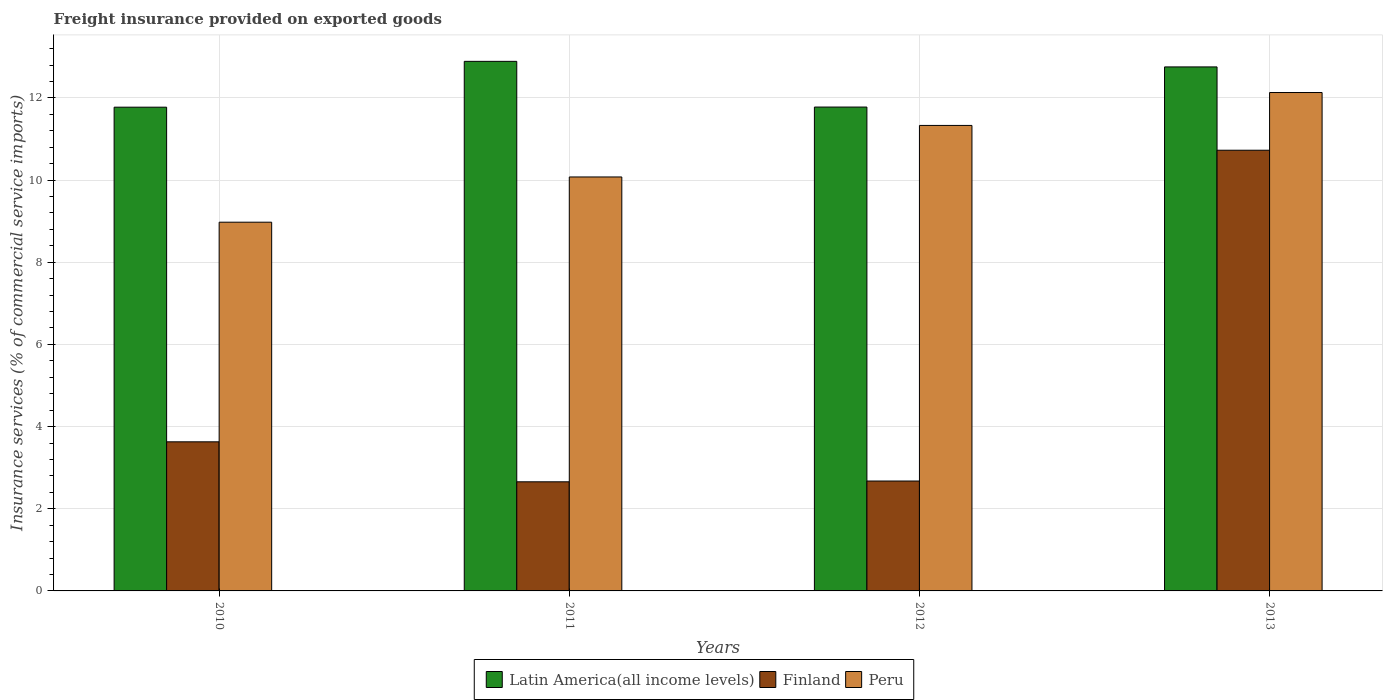How many different coloured bars are there?
Your answer should be very brief. 3. How many groups of bars are there?
Your answer should be compact. 4. Are the number of bars per tick equal to the number of legend labels?
Your response must be concise. Yes. What is the freight insurance provided on exported goods in Finland in 2012?
Your answer should be compact. 2.68. Across all years, what is the maximum freight insurance provided on exported goods in Finland?
Keep it short and to the point. 10.73. Across all years, what is the minimum freight insurance provided on exported goods in Latin America(all income levels)?
Provide a succinct answer. 11.77. In which year was the freight insurance provided on exported goods in Peru maximum?
Keep it short and to the point. 2013. What is the total freight insurance provided on exported goods in Finland in the graph?
Your response must be concise. 19.69. What is the difference between the freight insurance provided on exported goods in Finland in 2011 and that in 2012?
Your answer should be very brief. -0.02. What is the difference between the freight insurance provided on exported goods in Finland in 2010 and the freight insurance provided on exported goods in Latin America(all income levels) in 2013?
Your answer should be compact. -9.13. What is the average freight insurance provided on exported goods in Peru per year?
Your answer should be compact. 10.63. In the year 2011, what is the difference between the freight insurance provided on exported goods in Peru and freight insurance provided on exported goods in Finland?
Offer a terse response. 7.42. What is the ratio of the freight insurance provided on exported goods in Finland in 2011 to that in 2013?
Provide a short and direct response. 0.25. Is the difference between the freight insurance provided on exported goods in Peru in 2012 and 2013 greater than the difference between the freight insurance provided on exported goods in Finland in 2012 and 2013?
Offer a very short reply. Yes. What is the difference between the highest and the second highest freight insurance provided on exported goods in Peru?
Keep it short and to the point. 0.8. What is the difference between the highest and the lowest freight insurance provided on exported goods in Peru?
Keep it short and to the point. 3.16. In how many years, is the freight insurance provided on exported goods in Peru greater than the average freight insurance provided on exported goods in Peru taken over all years?
Give a very brief answer. 2. Is the sum of the freight insurance provided on exported goods in Latin America(all income levels) in 2010 and 2012 greater than the maximum freight insurance provided on exported goods in Peru across all years?
Your response must be concise. Yes. What does the 2nd bar from the left in 2010 represents?
Provide a succinct answer. Finland. What does the 1st bar from the right in 2012 represents?
Keep it short and to the point. Peru. How many bars are there?
Make the answer very short. 12. Are all the bars in the graph horizontal?
Your answer should be compact. No. What is the difference between two consecutive major ticks on the Y-axis?
Your answer should be compact. 2. Are the values on the major ticks of Y-axis written in scientific E-notation?
Make the answer very short. No. Does the graph contain any zero values?
Provide a succinct answer. No. Does the graph contain grids?
Keep it short and to the point. Yes. What is the title of the graph?
Ensure brevity in your answer.  Freight insurance provided on exported goods. Does "Uzbekistan" appear as one of the legend labels in the graph?
Your answer should be very brief. No. What is the label or title of the Y-axis?
Offer a very short reply. Insurance services (% of commercial service imports). What is the Insurance services (% of commercial service imports) of Latin America(all income levels) in 2010?
Your answer should be very brief. 11.77. What is the Insurance services (% of commercial service imports) of Finland in 2010?
Your answer should be very brief. 3.63. What is the Insurance services (% of commercial service imports) of Peru in 2010?
Provide a succinct answer. 8.98. What is the Insurance services (% of commercial service imports) of Latin America(all income levels) in 2011?
Offer a terse response. 12.89. What is the Insurance services (% of commercial service imports) in Finland in 2011?
Offer a terse response. 2.66. What is the Insurance services (% of commercial service imports) of Peru in 2011?
Your answer should be very brief. 10.08. What is the Insurance services (% of commercial service imports) in Latin America(all income levels) in 2012?
Your answer should be compact. 11.78. What is the Insurance services (% of commercial service imports) in Finland in 2012?
Your answer should be very brief. 2.68. What is the Insurance services (% of commercial service imports) in Peru in 2012?
Offer a terse response. 11.33. What is the Insurance services (% of commercial service imports) in Latin America(all income levels) in 2013?
Provide a succinct answer. 12.76. What is the Insurance services (% of commercial service imports) of Finland in 2013?
Offer a very short reply. 10.73. What is the Insurance services (% of commercial service imports) of Peru in 2013?
Offer a very short reply. 12.13. Across all years, what is the maximum Insurance services (% of commercial service imports) of Latin America(all income levels)?
Provide a short and direct response. 12.89. Across all years, what is the maximum Insurance services (% of commercial service imports) in Finland?
Offer a terse response. 10.73. Across all years, what is the maximum Insurance services (% of commercial service imports) of Peru?
Offer a terse response. 12.13. Across all years, what is the minimum Insurance services (% of commercial service imports) of Latin America(all income levels)?
Ensure brevity in your answer.  11.77. Across all years, what is the minimum Insurance services (% of commercial service imports) in Finland?
Keep it short and to the point. 2.66. Across all years, what is the minimum Insurance services (% of commercial service imports) in Peru?
Your answer should be compact. 8.98. What is the total Insurance services (% of commercial service imports) of Latin America(all income levels) in the graph?
Your answer should be very brief. 49.2. What is the total Insurance services (% of commercial service imports) in Finland in the graph?
Your response must be concise. 19.69. What is the total Insurance services (% of commercial service imports) of Peru in the graph?
Keep it short and to the point. 42.51. What is the difference between the Insurance services (% of commercial service imports) of Latin America(all income levels) in 2010 and that in 2011?
Your answer should be very brief. -1.12. What is the difference between the Insurance services (% of commercial service imports) of Finland in 2010 and that in 2011?
Offer a terse response. 0.97. What is the difference between the Insurance services (% of commercial service imports) of Peru in 2010 and that in 2011?
Offer a terse response. -1.1. What is the difference between the Insurance services (% of commercial service imports) in Latin America(all income levels) in 2010 and that in 2012?
Offer a very short reply. -0. What is the difference between the Insurance services (% of commercial service imports) of Finland in 2010 and that in 2012?
Offer a very short reply. 0.95. What is the difference between the Insurance services (% of commercial service imports) in Peru in 2010 and that in 2012?
Make the answer very short. -2.36. What is the difference between the Insurance services (% of commercial service imports) in Latin America(all income levels) in 2010 and that in 2013?
Give a very brief answer. -0.98. What is the difference between the Insurance services (% of commercial service imports) in Finland in 2010 and that in 2013?
Your answer should be very brief. -7.1. What is the difference between the Insurance services (% of commercial service imports) of Peru in 2010 and that in 2013?
Your response must be concise. -3.16. What is the difference between the Insurance services (% of commercial service imports) of Latin America(all income levels) in 2011 and that in 2012?
Ensure brevity in your answer.  1.11. What is the difference between the Insurance services (% of commercial service imports) of Finland in 2011 and that in 2012?
Your response must be concise. -0.02. What is the difference between the Insurance services (% of commercial service imports) of Peru in 2011 and that in 2012?
Keep it short and to the point. -1.25. What is the difference between the Insurance services (% of commercial service imports) of Latin America(all income levels) in 2011 and that in 2013?
Make the answer very short. 0.14. What is the difference between the Insurance services (% of commercial service imports) of Finland in 2011 and that in 2013?
Provide a succinct answer. -8.07. What is the difference between the Insurance services (% of commercial service imports) of Peru in 2011 and that in 2013?
Provide a succinct answer. -2.06. What is the difference between the Insurance services (% of commercial service imports) of Latin America(all income levels) in 2012 and that in 2013?
Your response must be concise. -0.98. What is the difference between the Insurance services (% of commercial service imports) in Finland in 2012 and that in 2013?
Your answer should be compact. -8.05. What is the difference between the Insurance services (% of commercial service imports) of Peru in 2012 and that in 2013?
Give a very brief answer. -0.8. What is the difference between the Insurance services (% of commercial service imports) in Latin America(all income levels) in 2010 and the Insurance services (% of commercial service imports) in Finland in 2011?
Ensure brevity in your answer.  9.12. What is the difference between the Insurance services (% of commercial service imports) in Latin America(all income levels) in 2010 and the Insurance services (% of commercial service imports) in Peru in 2011?
Provide a short and direct response. 1.7. What is the difference between the Insurance services (% of commercial service imports) of Finland in 2010 and the Insurance services (% of commercial service imports) of Peru in 2011?
Keep it short and to the point. -6.45. What is the difference between the Insurance services (% of commercial service imports) in Latin America(all income levels) in 2010 and the Insurance services (% of commercial service imports) in Finland in 2012?
Your answer should be compact. 9.1. What is the difference between the Insurance services (% of commercial service imports) of Latin America(all income levels) in 2010 and the Insurance services (% of commercial service imports) of Peru in 2012?
Ensure brevity in your answer.  0.44. What is the difference between the Insurance services (% of commercial service imports) of Finland in 2010 and the Insurance services (% of commercial service imports) of Peru in 2012?
Give a very brief answer. -7.7. What is the difference between the Insurance services (% of commercial service imports) of Latin America(all income levels) in 2010 and the Insurance services (% of commercial service imports) of Finland in 2013?
Provide a succinct answer. 1.05. What is the difference between the Insurance services (% of commercial service imports) of Latin America(all income levels) in 2010 and the Insurance services (% of commercial service imports) of Peru in 2013?
Ensure brevity in your answer.  -0.36. What is the difference between the Insurance services (% of commercial service imports) in Finland in 2010 and the Insurance services (% of commercial service imports) in Peru in 2013?
Provide a succinct answer. -8.5. What is the difference between the Insurance services (% of commercial service imports) in Latin America(all income levels) in 2011 and the Insurance services (% of commercial service imports) in Finland in 2012?
Your response must be concise. 10.22. What is the difference between the Insurance services (% of commercial service imports) of Latin America(all income levels) in 2011 and the Insurance services (% of commercial service imports) of Peru in 2012?
Provide a short and direct response. 1.56. What is the difference between the Insurance services (% of commercial service imports) of Finland in 2011 and the Insurance services (% of commercial service imports) of Peru in 2012?
Ensure brevity in your answer.  -8.67. What is the difference between the Insurance services (% of commercial service imports) in Latin America(all income levels) in 2011 and the Insurance services (% of commercial service imports) in Finland in 2013?
Ensure brevity in your answer.  2.16. What is the difference between the Insurance services (% of commercial service imports) in Latin America(all income levels) in 2011 and the Insurance services (% of commercial service imports) in Peru in 2013?
Provide a short and direct response. 0.76. What is the difference between the Insurance services (% of commercial service imports) of Finland in 2011 and the Insurance services (% of commercial service imports) of Peru in 2013?
Make the answer very short. -9.48. What is the difference between the Insurance services (% of commercial service imports) of Latin America(all income levels) in 2012 and the Insurance services (% of commercial service imports) of Finland in 2013?
Offer a terse response. 1.05. What is the difference between the Insurance services (% of commercial service imports) in Latin America(all income levels) in 2012 and the Insurance services (% of commercial service imports) in Peru in 2013?
Provide a succinct answer. -0.35. What is the difference between the Insurance services (% of commercial service imports) in Finland in 2012 and the Insurance services (% of commercial service imports) in Peru in 2013?
Provide a short and direct response. -9.46. What is the average Insurance services (% of commercial service imports) of Latin America(all income levels) per year?
Give a very brief answer. 12.3. What is the average Insurance services (% of commercial service imports) of Finland per year?
Provide a succinct answer. 4.92. What is the average Insurance services (% of commercial service imports) of Peru per year?
Keep it short and to the point. 10.63. In the year 2010, what is the difference between the Insurance services (% of commercial service imports) of Latin America(all income levels) and Insurance services (% of commercial service imports) of Finland?
Make the answer very short. 8.15. In the year 2010, what is the difference between the Insurance services (% of commercial service imports) of Latin America(all income levels) and Insurance services (% of commercial service imports) of Peru?
Keep it short and to the point. 2.8. In the year 2010, what is the difference between the Insurance services (% of commercial service imports) in Finland and Insurance services (% of commercial service imports) in Peru?
Keep it short and to the point. -5.35. In the year 2011, what is the difference between the Insurance services (% of commercial service imports) of Latin America(all income levels) and Insurance services (% of commercial service imports) of Finland?
Your answer should be very brief. 10.23. In the year 2011, what is the difference between the Insurance services (% of commercial service imports) of Latin America(all income levels) and Insurance services (% of commercial service imports) of Peru?
Keep it short and to the point. 2.81. In the year 2011, what is the difference between the Insurance services (% of commercial service imports) in Finland and Insurance services (% of commercial service imports) in Peru?
Offer a very short reply. -7.42. In the year 2012, what is the difference between the Insurance services (% of commercial service imports) in Latin America(all income levels) and Insurance services (% of commercial service imports) in Finland?
Offer a terse response. 9.1. In the year 2012, what is the difference between the Insurance services (% of commercial service imports) of Latin America(all income levels) and Insurance services (% of commercial service imports) of Peru?
Offer a very short reply. 0.45. In the year 2012, what is the difference between the Insurance services (% of commercial service imports) in Finland and Insurance services (% of commercial service imports) in Peru?
Provide a succinct answer. -8.66. In the year 2013, what is the difference between the Insurance services (% of commercial service imports) of Latin America(all income levels) and Insurance services (% of commercial service imports) of Finland?
Make the answer very short. 2.03. In the year 2013, what is the difference between the Insurance services (% of commercial service imports) in Latin America(all income levels) and Insurance services (% of commercial service imports) in Peru?
Give a very brief answer. 0.62. In the year 2013, what is the difference between the Insurance services (% of commercial service imports) of Finland and Insurance services (% of commercial service imports) of Peru?
Offer a terse response. -1.4. What is the ratio of the Insurance services (% of commercial service imports) in Latin America(all income levels) in 2010 to that in 2011?
Your answer should be very brief. 0.91. What is the ratio of the Insurance services (% of commercial service imports) of Finland in 2010 to that in 2011?
Keep it short and to the point. 1.37. What is the ratio of the Insurance services (% of commercial service imports) in Peru in 2010 to that in 2011?
Your response must be concise. 0.89. What is the ratio of the Insurance services (% of commercial service imports) in Latin America(all income levels) in 2010 to that in 2012?
Your answer should be very brief. 1. What is the ratio of the Insurance services (% of commercial service imports) of Finland in 2010 to that in 2012?
Ensure brevity in your answer.  1.36. What is the ratio of the Insurance services (% of commercial service imports) in Peru in 2010 to that in 2012?
Offer a terse response. 0.79. What is the ratio of the Insurance services (% of commercial service imports) of Finland in 2010 to that in 2013?
Offer a terse response. 0.34. What is the ratio of the Insurance services (% of commercial service imports) in Peru in 2010 to that in 2013?
Your answer should be very brief. 0.74. What is the ratio of the Insurance services (% of commercial service imports) in Latin America(all income levels) in 2011 to that in 2012?
Give a very brief answer. 1.09. What is the ratio of the Insurance services (% of commercial service imports) of Finland in 2011 to that in 2012?
Provide a succinct answer. 0.99. What is the ratio of the Insurance services (% of commercial service imports) in Peru in 2011 to that in 2012?
Offer a terse response. 0.89. What is the ratio of the Insurance services (% of commercial service imports) in Latin America(all income levels) in 2011 to that in 2013?
Your response must be concise. 1.01. What is the ratio of the Insurance services (% of commercial service imports) in Finland in 2011 to that in 2013?
Keep it short and to the point. 0.25. What is the ratio of the Insurance services (% of commercial service imports) in Peru in 2011 to that in 2013?
Provide a succinct answer. 0.83. What is the ratio of the Insurance services (% of commercial service imports) of Latin America(all income levels) in 2012 to that in 2013?
Ensure brevity in your answer.  0.92. What is the ratio of the Insurance services (% of commercial service imports) in Finland in 2012 to that in 2013?
Your answer should be compact. 0.25. What is the ratio of the Insurance services (% of commercial service imports) in Peru in 2012 to that in 2013?
Provide a succinct answer. 0.93. What is the difference between the highest and the second highest Insurance services (% of commercial service imports) of Latin America(all income levels)?
Give a very brief answer. 0.14. What is the difference between the highest and the second highest Insurance services (% of commercial service imports) of Finland?
Offer a very short reply. 7.1. What is the difference between the highest and the second highest Insurance services (% of commercial service imports) in Peru?
Offer a very short reply. 0.8. What is the difference between the highest and the lowest Insurance services (% of commercial service imports) in Latin America(all income levels)?
Your answer should be very brief. 1.12. What is the difference between the highest and the lowest Insurance services (% of commercial service imports) in Finland?
Offer a very short reply. 8.07. What is the difference between the highest and the lowest Insurance services (% of commercial service imports) of Peru?
Give a very brief answer. 3.16. 